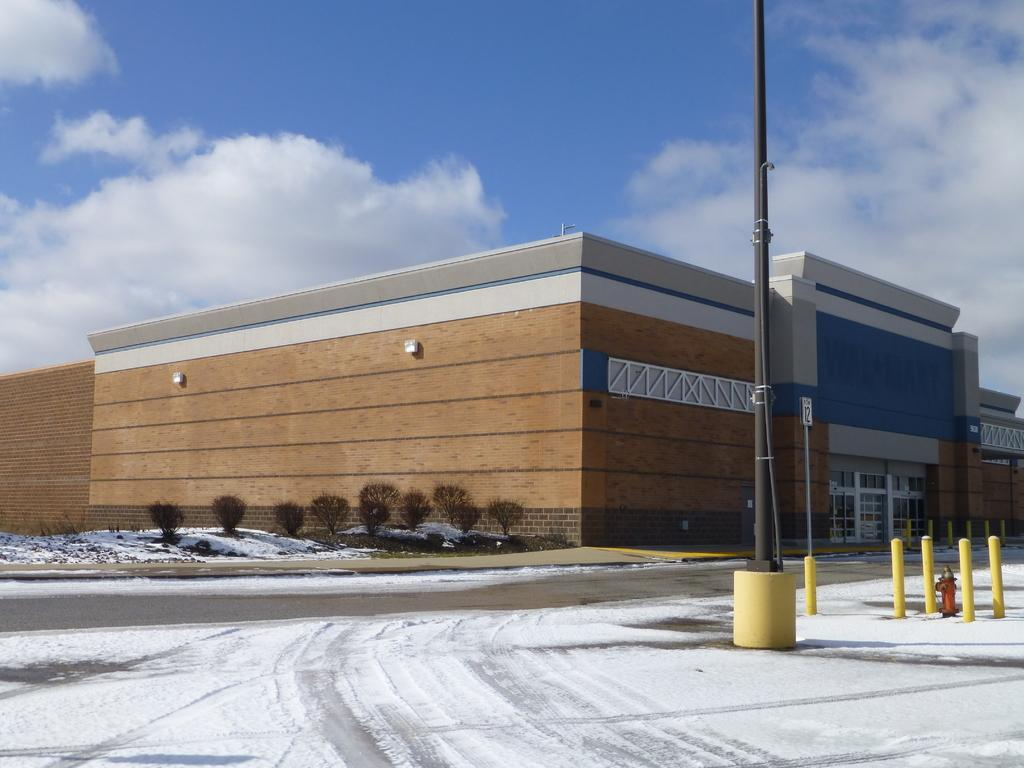What type of structure is present in the image? There is a building in the image. What is the pole used for in the image? The purpose of the pole is not specified in the image. What type of vegetation can be seen in the image? There are trees in the image. What type of surface is visible in the image? There is a road in the image. What is the weather like in the image? There is snow in the image, indicating a cold or wintery weather. What is visible in the background of the image? There is a sky visible in the background of the image, with clouds present. What type of silk is being produced in the building in the image? There is no indication of silk production or any industry in the image; it only shows a building, a pole, trees, a road, snow, and a sky with clouds. How many clouds are visible on the cloud in the image? The question is unclear and seems to be based on a misunderstanding. There are clouds visible in the background of the image, but they are not referred to as "the cloud" in the image. 